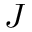<formula> <loc_0><loc_0><loc_500><loc_500>J</formula> 